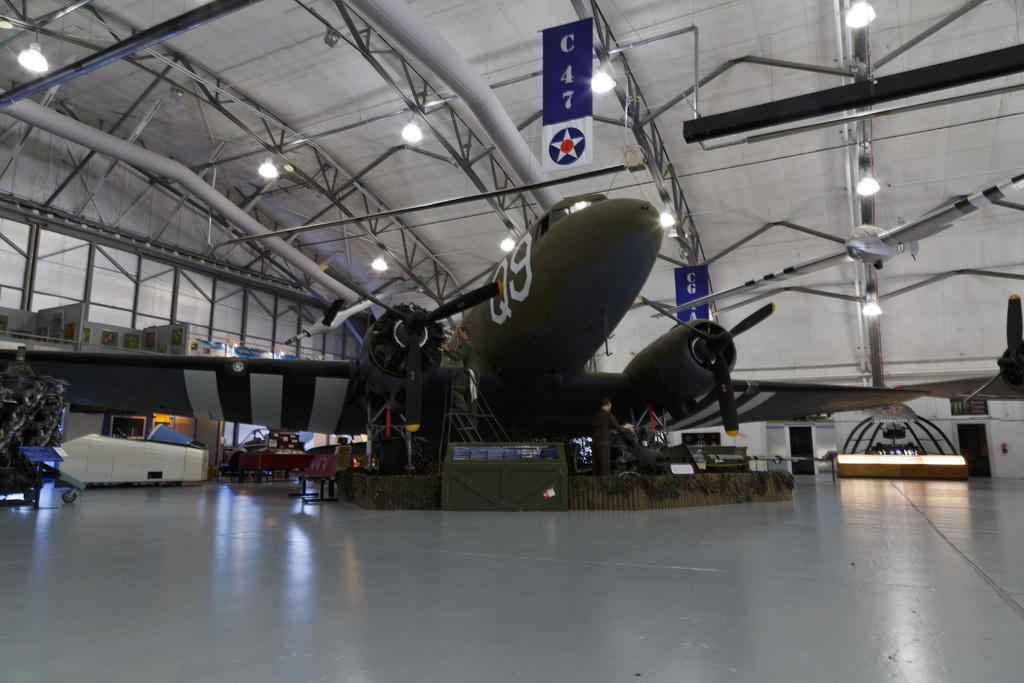<image>
Share a concise interpretation of the image provided. A plane with the letter Q and number 9 written on the front 